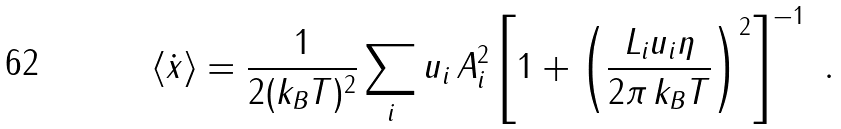Convert formula to latex. <formula><loc_0><loc_0><loc_500><loc_500>\langle \dot { x } \rangle = \frac { 1 } { 2 ( k _ { B } T ) ^ { 2 } } \sum _ { i } u _ { i } \, A _ { i } ^ { 2 } \left [ 1 + \left ( \frac { L _ { i } u _ { i } \eta } { 2 \pi \, k _ { B } T } \right ) ^ { 2 } \right ] ^ { - 1 } \ .</formula> 